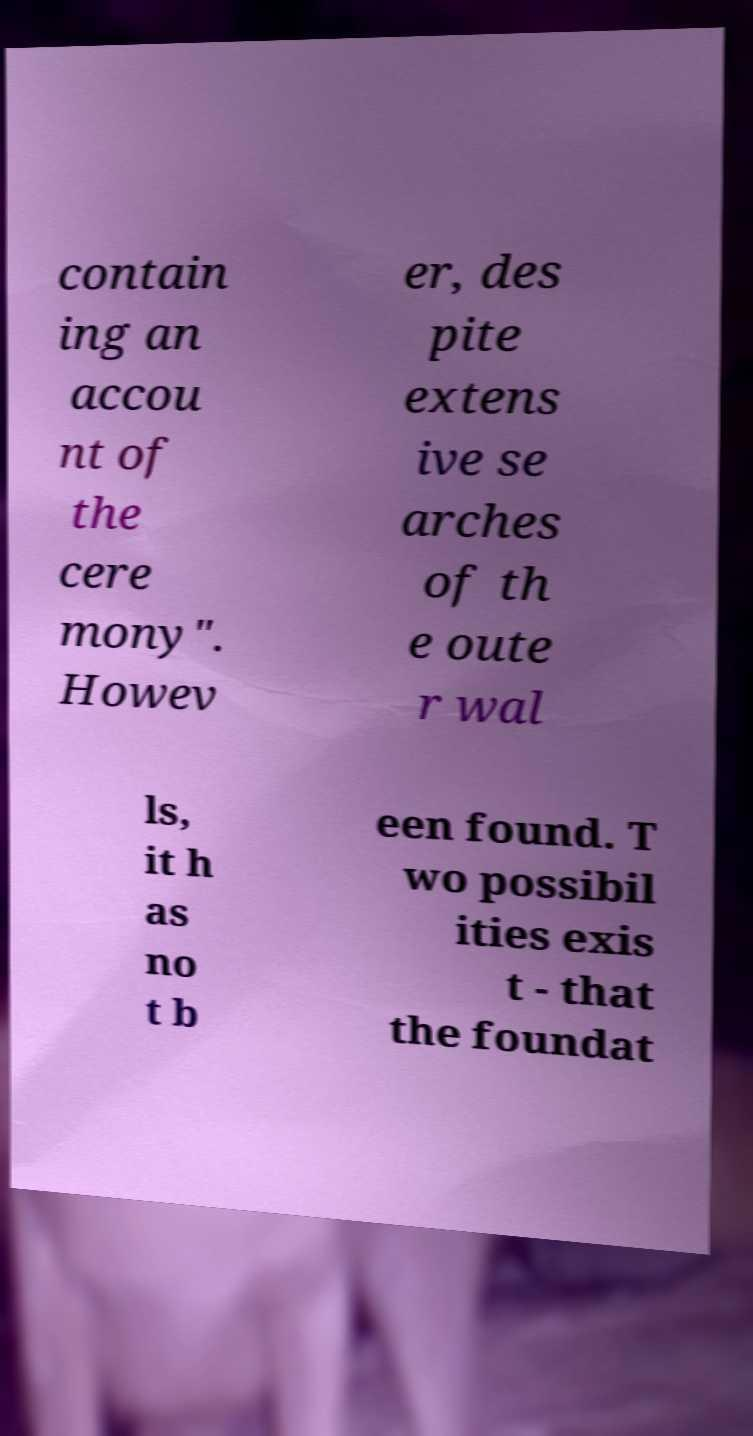Could you extract and type out the text from this image? contain ing an accou nt of the cere mony". Howev er, des pite extens ive se arches of th e oute r wal ls, it h as no t b een found. T wo possibil ities exis t - that the foundat 